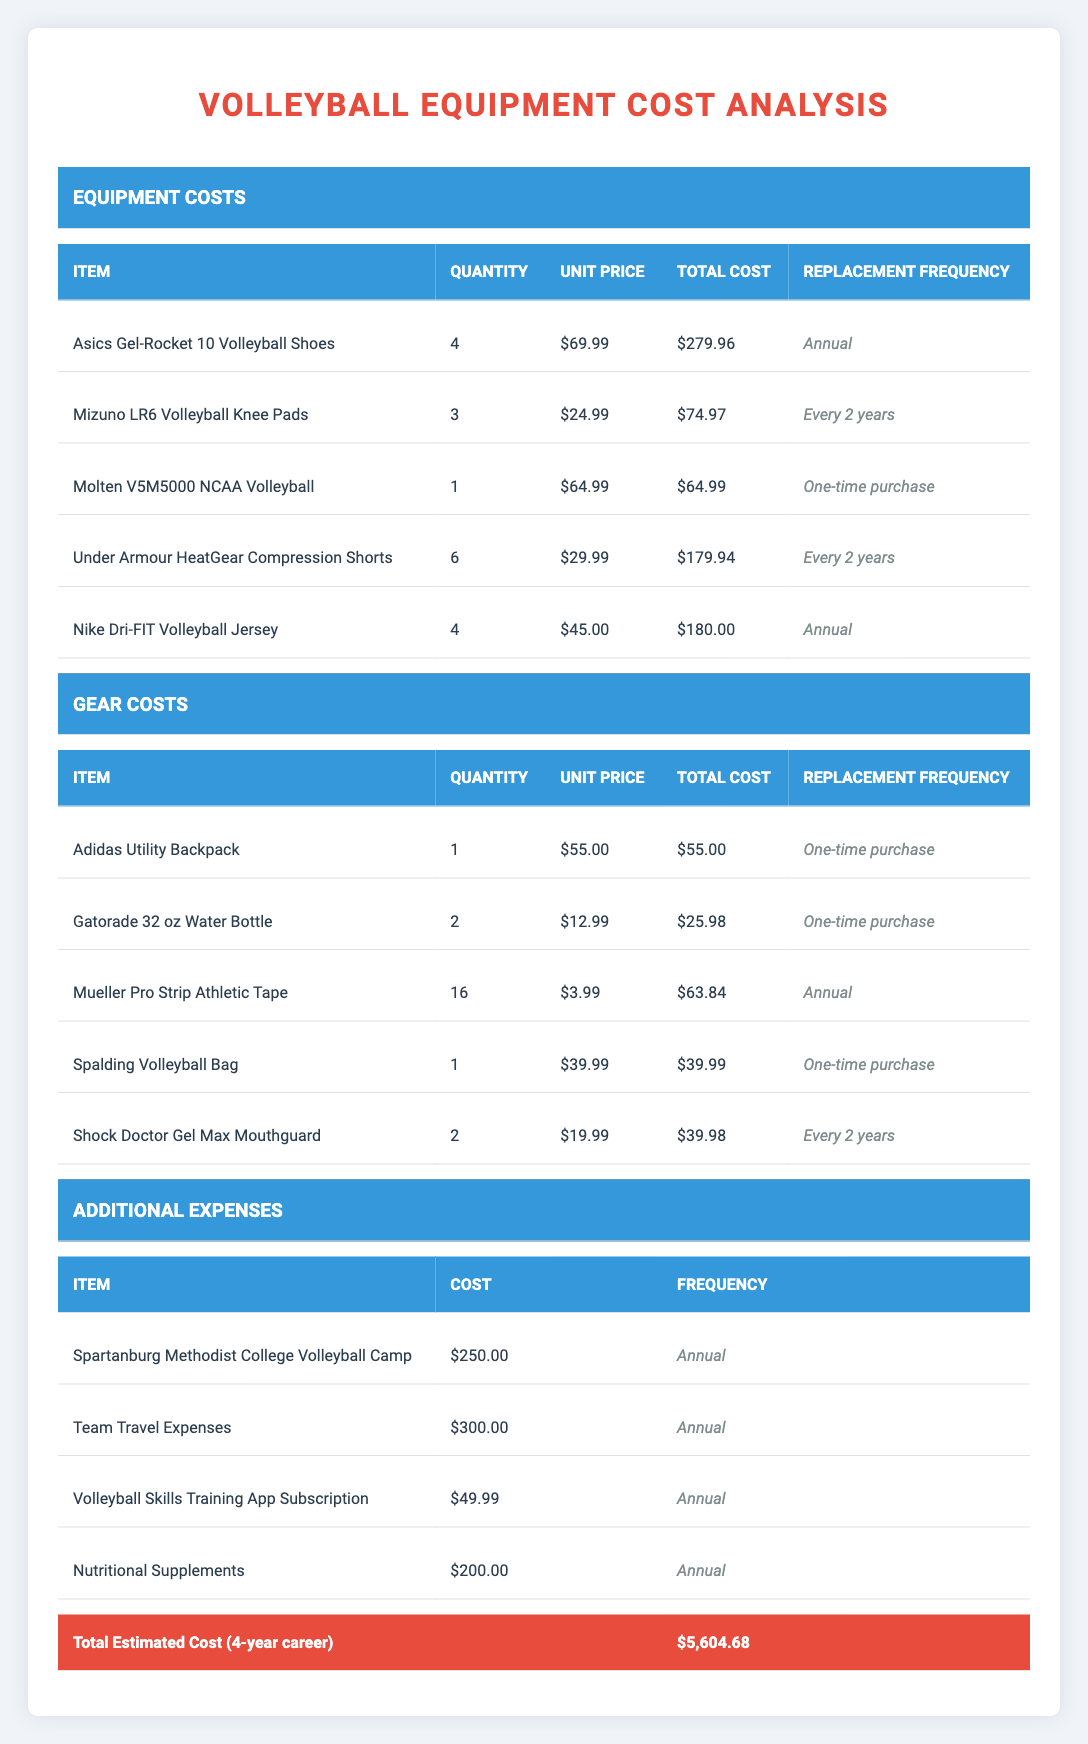What is the total cost for Asics Gel-Rocket 10 Volleyball Shoes over a four-year college career? Since the replacement frequency is annual and the unit price is $69.99, the total cost for four years would be calculated as 4 * $69.99 = $279.96.
Answer: $279.96 How many items have a replacement frequency of "Every 2 years"? By reviewing the table, the Mizuno LR6 Volleyball Knee Pads and the Under Armour HeatGear Compression Shorts have a replacement frequency of "Every 2 years," totaling to 2 items.
Answer: 2 What is the total cost of gear needed for a four-year college career? The total cost for each gear item does not require replacement; thus we sum the total costs of the Adidas Utility Backpack ($55.00), Gatorade Water Bottles ($25.98), Mueller Athletic Tape ($63.84), Spalding Volleyball Bag ($39.99), and Shock Doctor Mouthguard ($39.98). The total is $55.00 + $25.98 + $63.84 + $39.99 + $39.98 = $224.79.
Answer: $224.79 Is the total estimated cost for a four-year college career greater than $5,500? The total estimated cost listed in the table is $5,604.68, which is indeed greater than $5,500.
Answer: Yes What is the average annual expense for participating in the Spartanburg Methodist College Volleyball Program? The additional annual expenses total $250.00 (Volleyball Camp) + $300.00 (Travel Expenses) + $49.99 (Training App Subscription) + $200.00 (Nutritional Supplements) = $800.99. To find the average, divide by 4 years: $800.99 / 4 = $200.25 per year.
Answer: $200.25 How many items are considered one-time purchases in the equipment costs? Looking at the equipment costs, the Molten Volleyball is marked as a one-time purchase. The total count of one-time purchases is 1.
Answer: 1 What is the total estimated cost for all additional expenses over four years? The additional expenses are all annual. Thus, the total for four years is $250.00 + $300.00 + $49.99 + $200.00 = $800.99, and over four years that would be $800.99 * 4 = $3,203.96.
Answer: $3,203.96 How much would a student pay for their volleyball jersey over four years? The frequency of the Nike Dri-FIT Volleyball Jersey is annual, at a total cost of $180.00 each year for four years: $180.00 * 4 = $720.00.
Answer: $720.00 How many items total require annual replacement? The table indicates that the Asics Gel-Rocket 10 Volleyball Shoes, Nike Dri-FIT Volleyball Jersey, and Mueller Athletic Tape require annual replacement, making a total of 3 items.
Answer: 3 